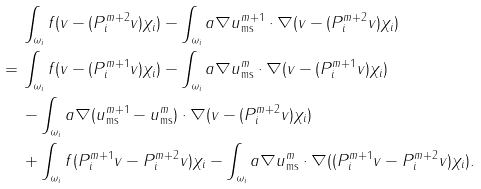Convert formula to latex. <formula><loc_0><loc_0><loc_500><loc_500>& \, \int _ { \omega _ { i } } f ( v - ( P _ { i } ^ { m + 2 } v ) \chi _ { i } ) - \int _ { \omega _ { i } } a \nabla u _ { \text {ms} } ^ { m + 1 } \cdot \nabla ( v - ( P _ { i } ^ { m + 2 } v ) \chi _ { i } ) \\ = & \, \int _ { \omega _ { i } } f ( v - ( P _ { i } ^ { m + 1 } v ) \chi _ { i } ) - \int _ { \omega _ { i } } a \nabla u _ { \text {ms} } ^ { m } \cdot \nabla ( v - ( P _ { i } ^ { m + 1 } v ) \chi _ { i } ) \\ & \, - \int _ { \omega _ { i } } a \nabla ( u _ { \text {ms} } ^ { m + 1 } - u _ { \text {ms} } ^ { m } ) \cdot \nabla ( v - ( P _ { i } ^ { m + 2 } v ) \chi _ { i } ) \\ & \, + \int _ { \omega _ { i } } f ( P _ { i } ^ { m + 1 } v - P _ { i } ^ { m + 2 } v ) \chi _ { i } - \int _ { \omega _ { i } } a \nabla u _ { \text {ms} } ^ { m } \cdot \nabla ( ( P _ { i } ^ { m + 1 } v - P _ { i } ^ { m + 2 } v ) \chi _ { i } ) .</formula> 